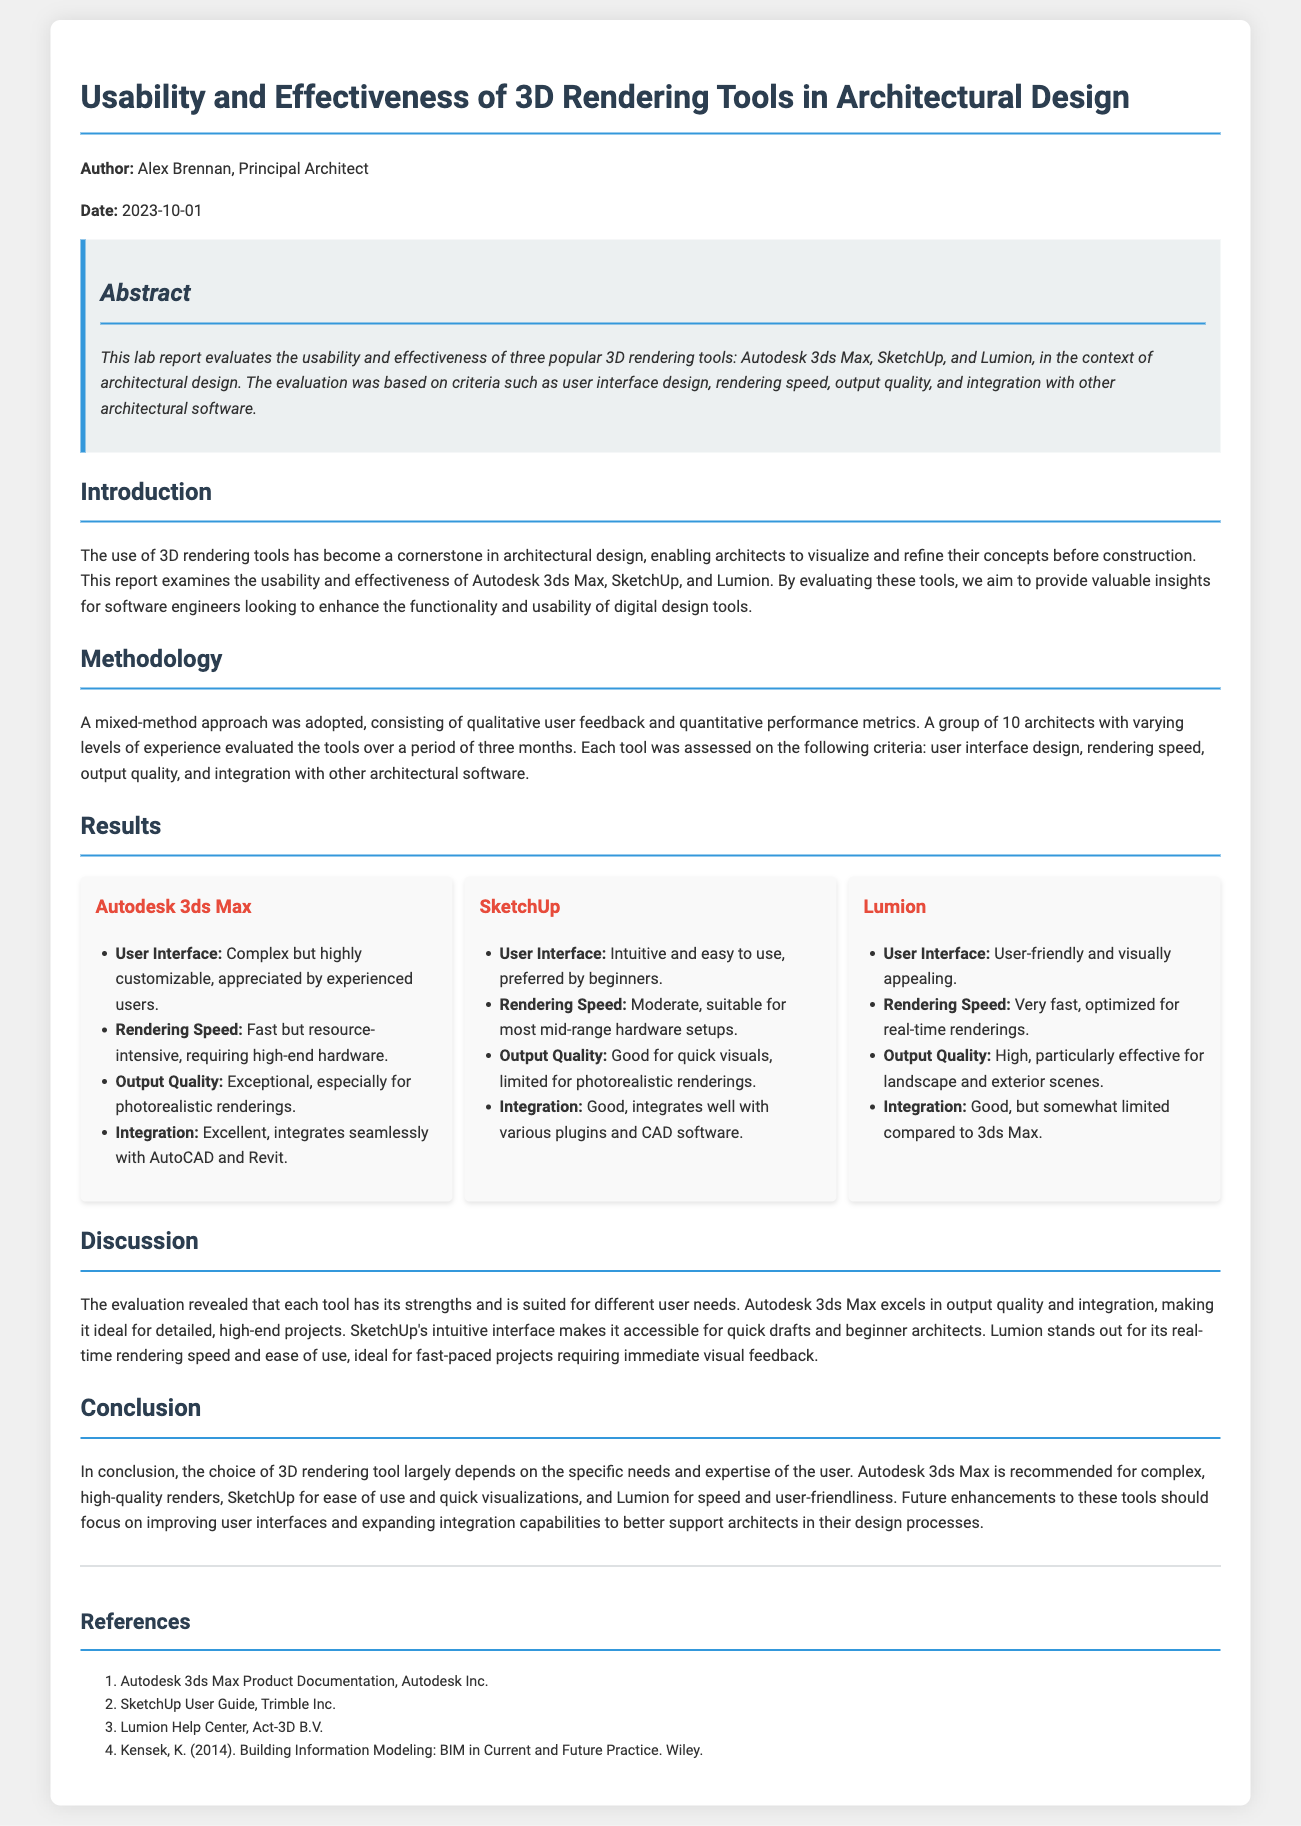What is the title of the lab report? The title of the lab report is found in the heading section of the document, which is "Usability and Effectiveness of 3D Rendering Tools in Architectural Design."
Answer: Usability and Effectiveness of 3D Rendering Tools in Architectural Design Who authored the lab report? The author of the lab report is mentioned in the introductory section, specifically listed as Alex Brennan.
Answer: Alex Brennan What date was the lab report published? The publication date is provided right after the author's name, which is October 1, 2023.
Answer: 2023-10-01 How many architects participated in the evaluation? The number of architects is stated in the Methodology section, indicating that a group of 10 architects participated.
Answer: 10 Which tool is noted for its exceptional output quality? The tool known for its outstanding output quality is mentioned under the Results section, specifically referencing Autodesk 3ds Max.
Answer: Autodesk 3ds Max What rendering speed is associated with Lumion? The rendering speed information for Lumion is found under its Results description, stating it is "very fast."
Answer: Very fast Which tool is preferred by beginners for its user interface? SketchUp is highlighted in the document for its user-friendly and intuitive interface, making it preferred by beginners.
Answer: SketchUp What is the primary recommendation for Autodesk 3ds Max? The primary recommendation is stated in the Conclusion section, where it is recommended for "complex, high-quality renders."
Answer: Complex, high-quality renders In which section does the discussion of integration capabilities appear? The integration capabilities are discussed in the Results section, which evaluates how well each tool integrates with other architectural software.
Answer: Results 